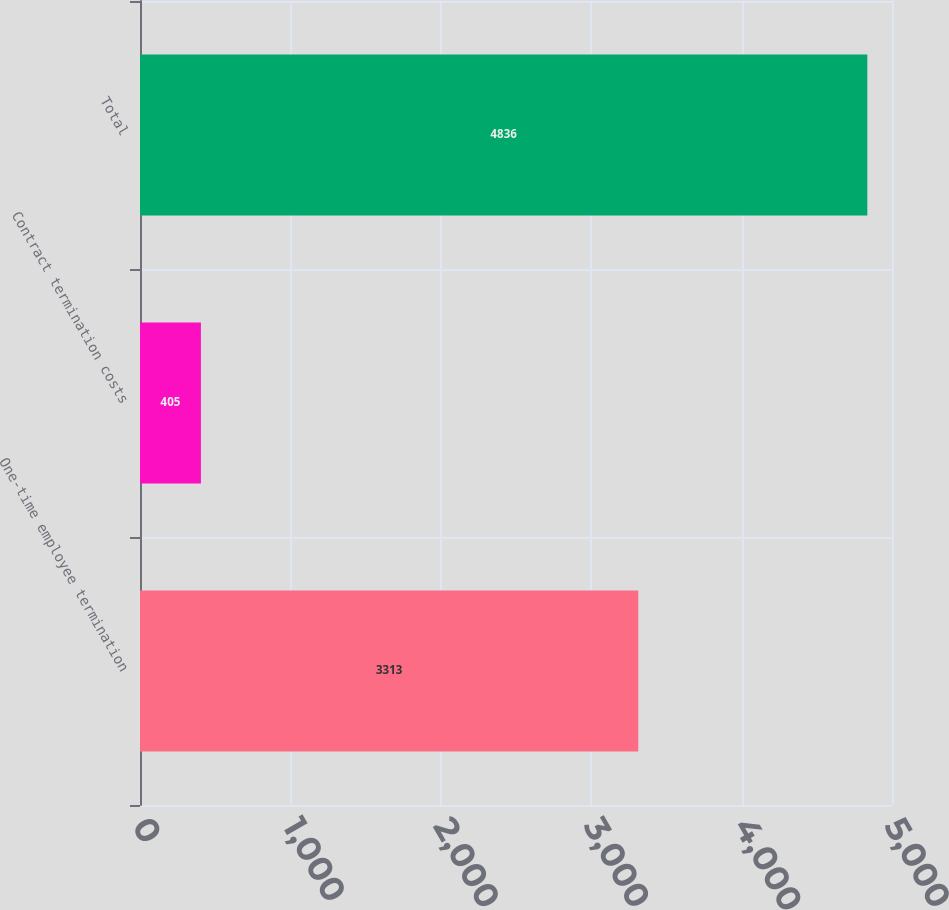Convert chart. <chart><loc_0><loc_0><loc_500><loc_500><bar_chart><fcel>One-time employee termination<fcel>Contract termination costs<fcel>Total<nl><fcel>3313<fcel>405<fcel>4836<nl></chart> 